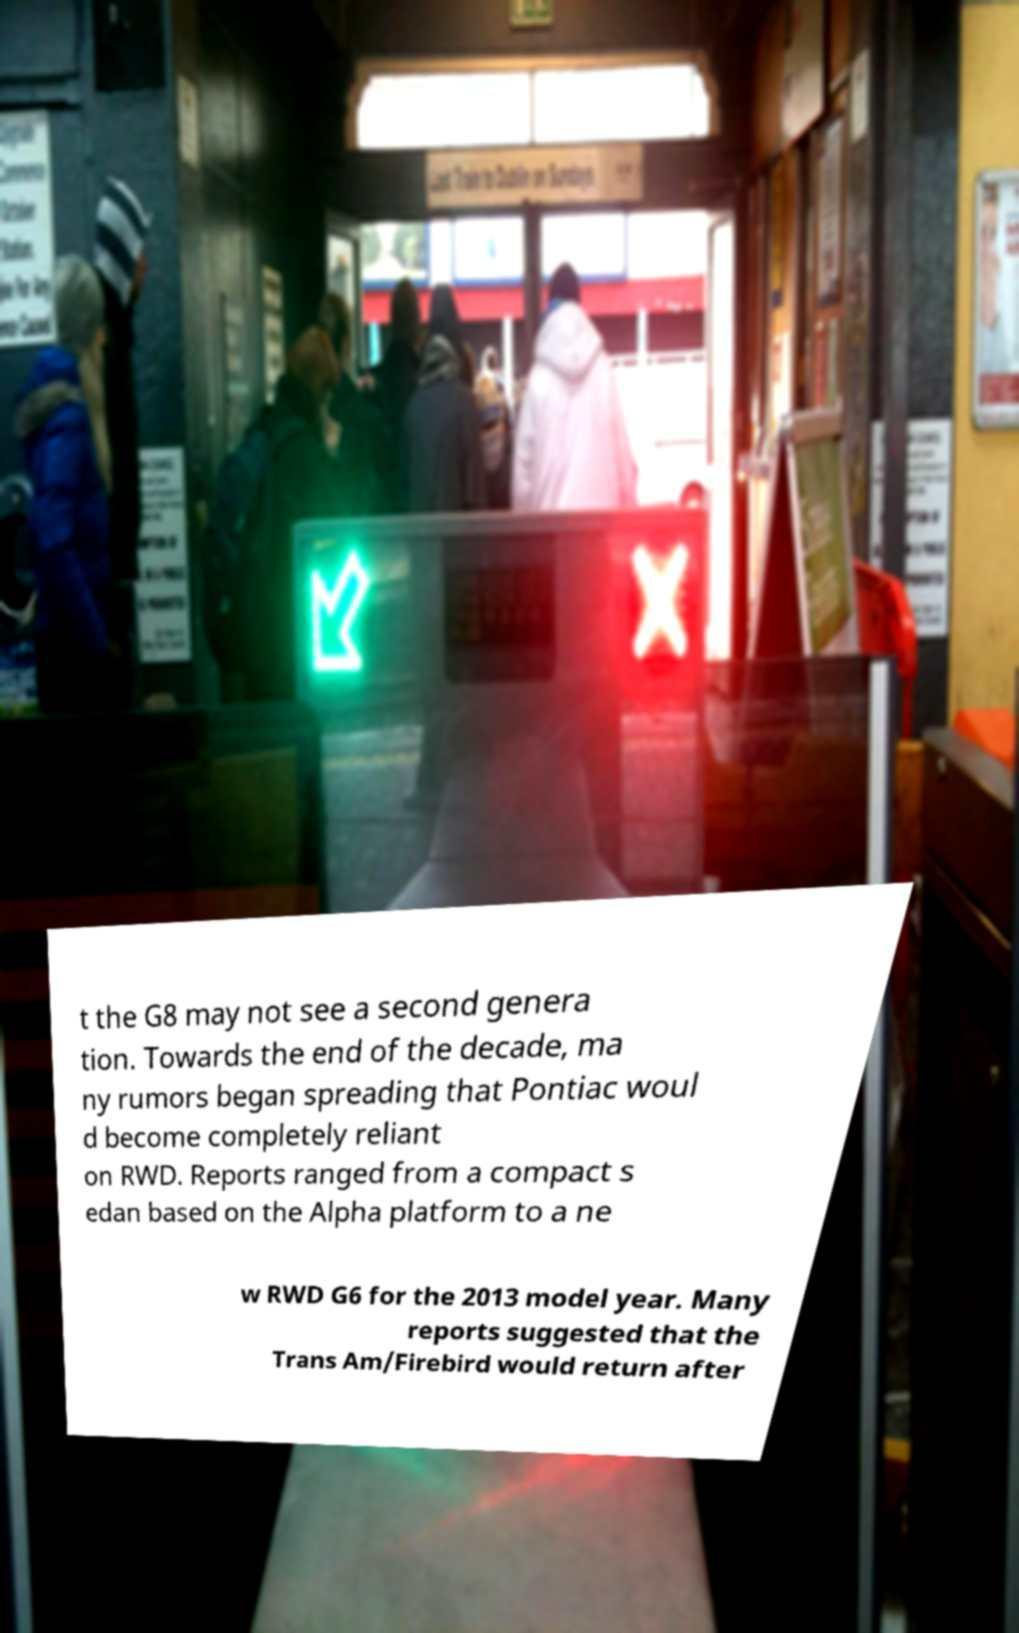Could you assist in decoding the text presented in this image and type it out clearly? t the G8 may not see a second genera tion. Towards the end of the decade, ma ny rumors began spreading that Pontiac woul d become completely reliant on RWD. Reports ranged from a compact s edan based on the Alpha platform to a ne w RWD G6 for the 2013 model year. Many reports suggested that the Trans Am/Firebird would return after 